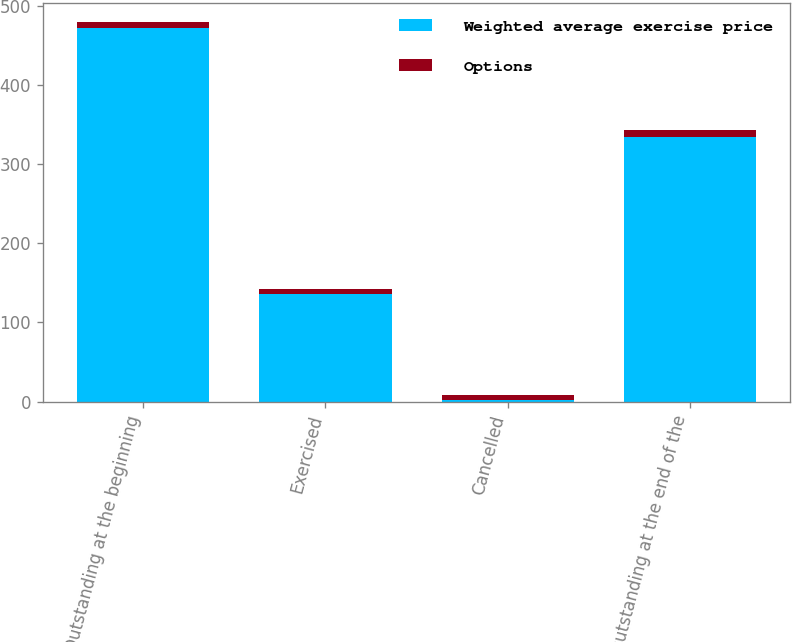Convert chart. <chart><loc_0><loc_0><loc_500><loc_500><stacked_bar_chart><ecel><fcel>Outstanding at the beginning<fcel>Exercised<fcel>Cancelled<fcel>Outstanding at the end of the<nl><fcel>Weighted average exercise price<fcel>473<fcel>136<fcel>2<fcel>335<nl><fcel>Options<fcel>7.61<fcel>6.58<fcel>5.9<fcel>8.04<nl></chart> 